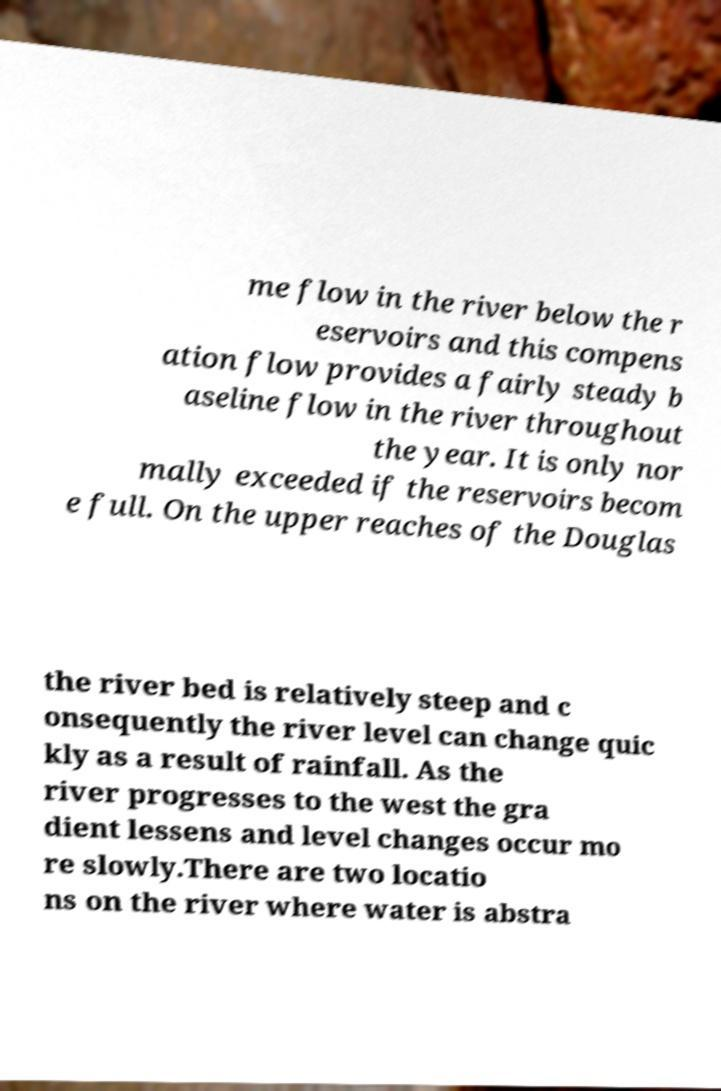I need the written content from this picture converted into text. Can you do that? me flow in the river below the r eservoirs and this compens ation flow provides a fairly steady b aseline flow in the river throughout the year. It is only nor mally exceeded if the reservoirs becom e full. On the upper reaches of the Douglas the river bed is relatively steep and c onsequently the river level can change quic kly as a result of rainfall. As the river progresses to the west the gra dient lessens and level changes occur mo re slowly.There are two locatio ns on the river where water is abstra 